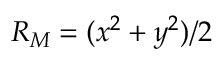<formula> <loc_0><loc_0><loc_500><loc_500>R _ { M } = ( x ^ { 2 } + y ^ { 2 } ) / 2</formula> 